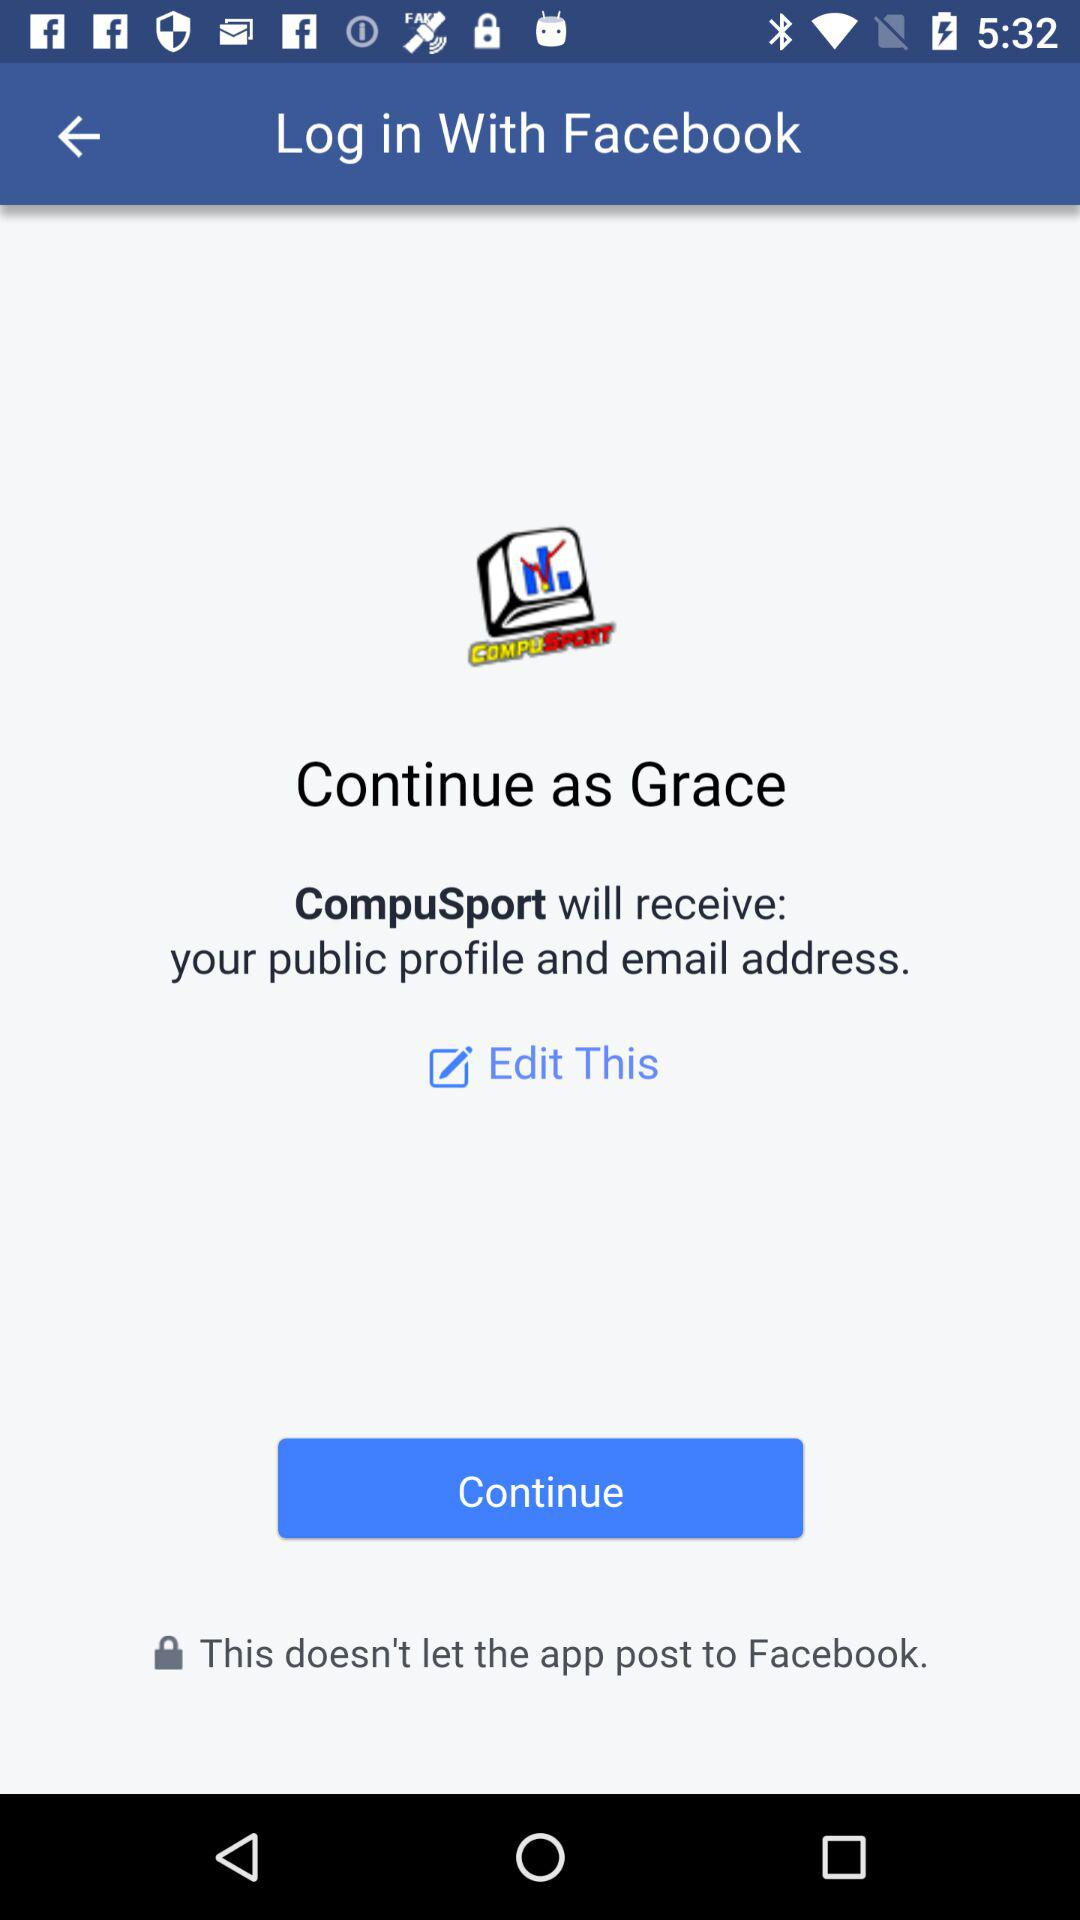What application is asking for permission? The application "CompuSport" is asking for permission. 